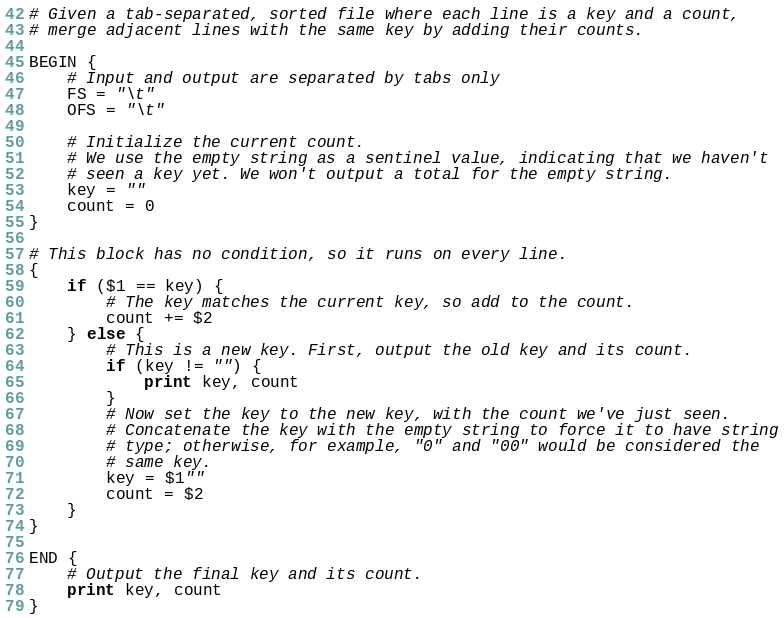Convert code to text. <code><loc_0><loc_0><loc_500><loc_500><_Awk_># Given a tab-separated, sorted file where each line is a key and a count,
# merge adjacent lines with the same key by adding their counts.

BEGIN {
    # Input and output are separated by tabs only
    FS = "\t"
    OFS = "\t"

    # Initialize the current count.
    # We use the empty string as a sentinel value, indicating that we haven't
    # seen a key yet. We won't output a total for the empty string.
    key = ""
    count = 0
}

# This block has no condition, so it runs on every line.
{
    if ($1 == key) {
        # The key matches the current key, so add to the count.
        count += $2
    } else {
        # This is a new key. First, output the old key and its count.
        if (key != "") {
            print key, count
        }
        # Now set the key to the new key, with the count we've just seen.
        # Concatenate the key with the empty string to force it to have string
        # type; otherwise, for example, "0" and "00" would be considered the
        # same key.
        key = $1""
        count = $2
    }
}

END {
    # Output the final key and its count.
    print key, count
}
</code> 